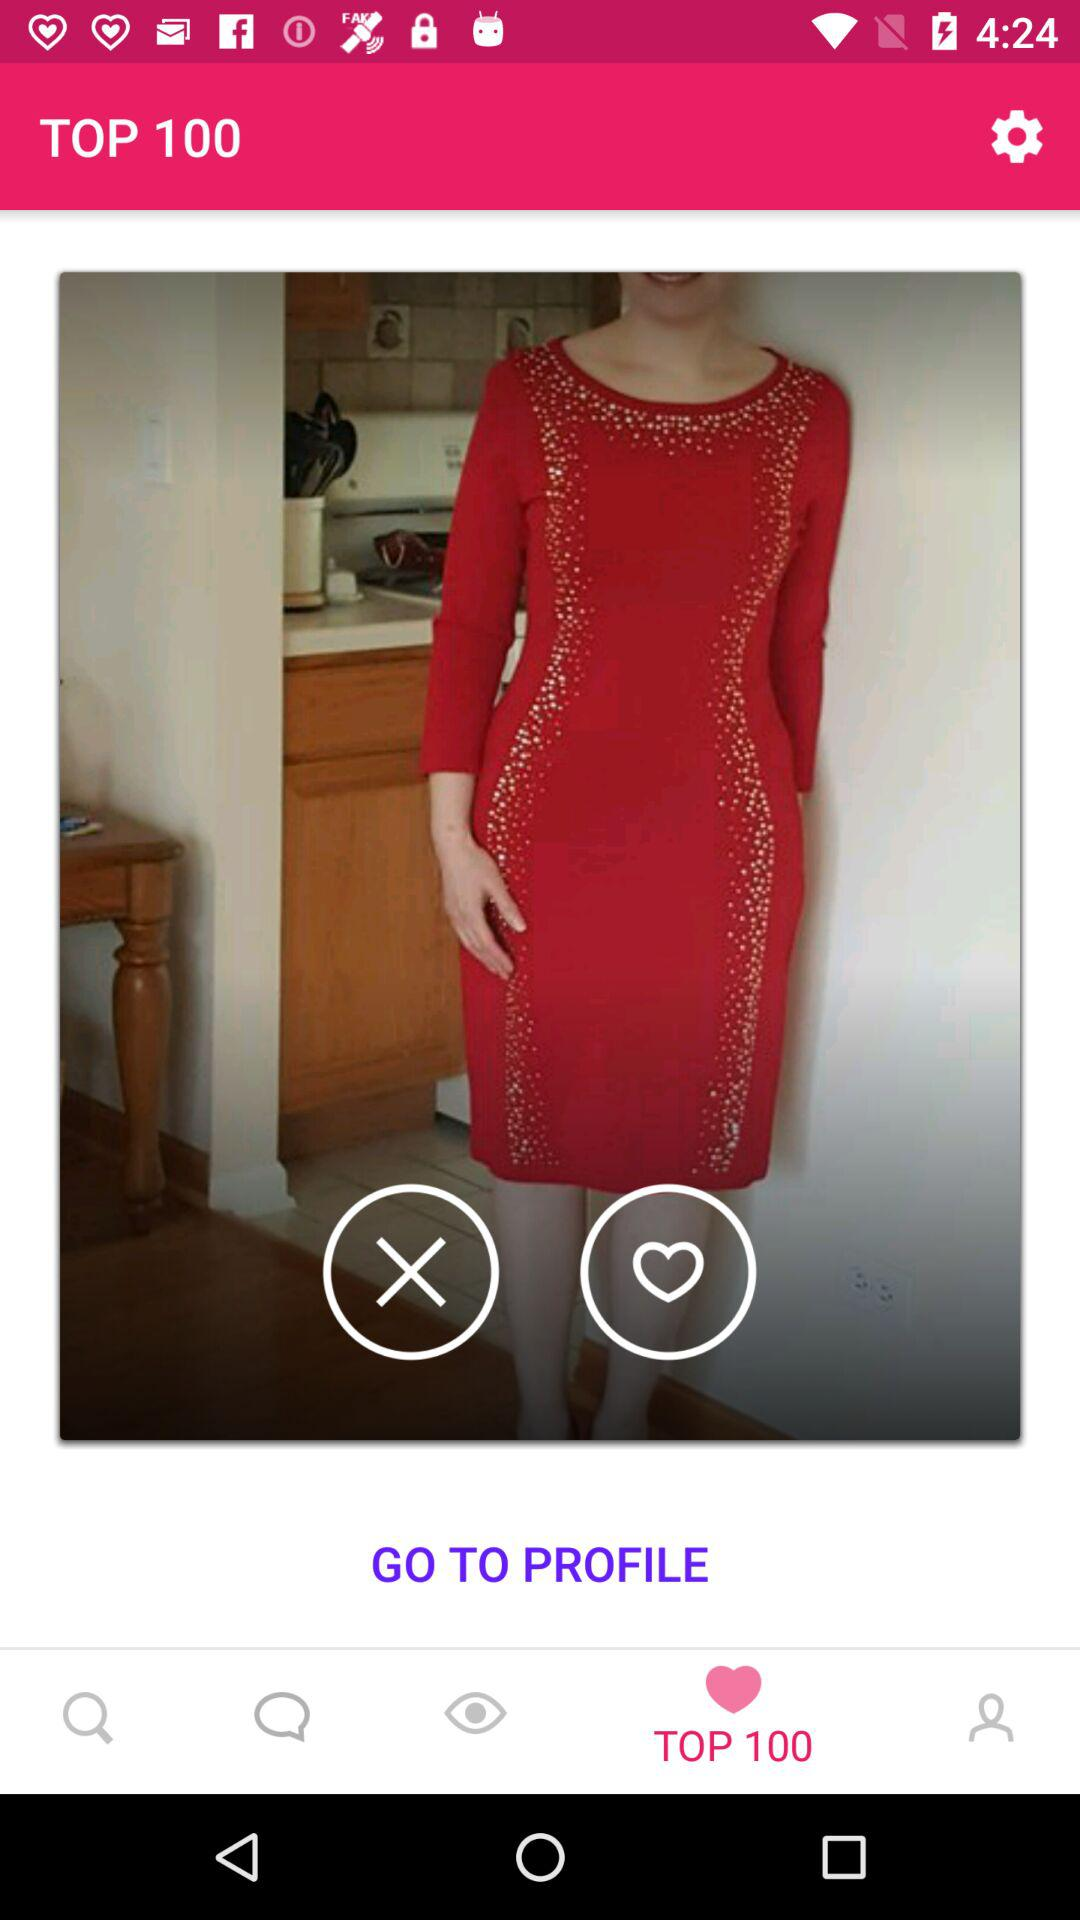What is the selected tab? The selected tab is "TOP 100". 